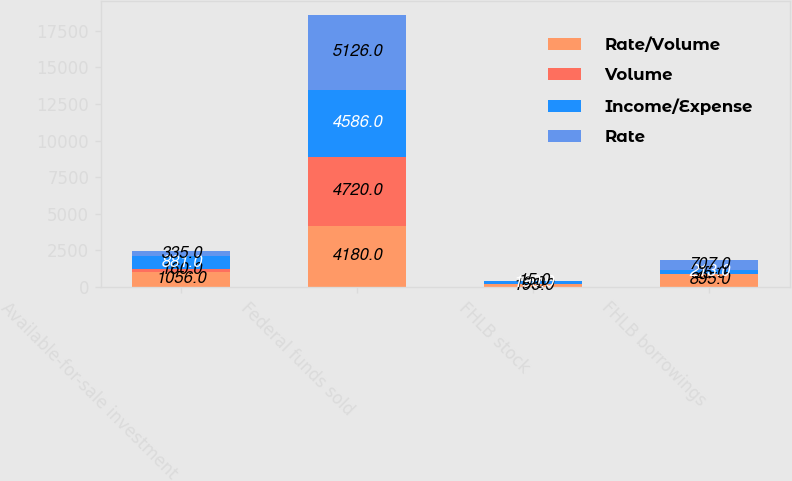Convert chart. <chart><loc_0><loc_0><loc_500><loc_500><stacked_bar_chart><ecel><fcel>Available-for-sale investment<fcel>Federal funds sold<fcel>FHLB stock<fcel>FHLB borrowings<nl><fcel>Rate/Volume<fcel>1056<fcel>4180<fcel>196<fcel>895<nl><fcel>Volume<fcel>160<fcel>4720<fcel>9<fcel>25<nl><fcel>Income/Expense<fcel>881<fcel>4586<fcel>190<fcel>213<nl><fcel>Rate<fcel>335<fcel>5126<fcel>15<fcel>707<nl></chart> 